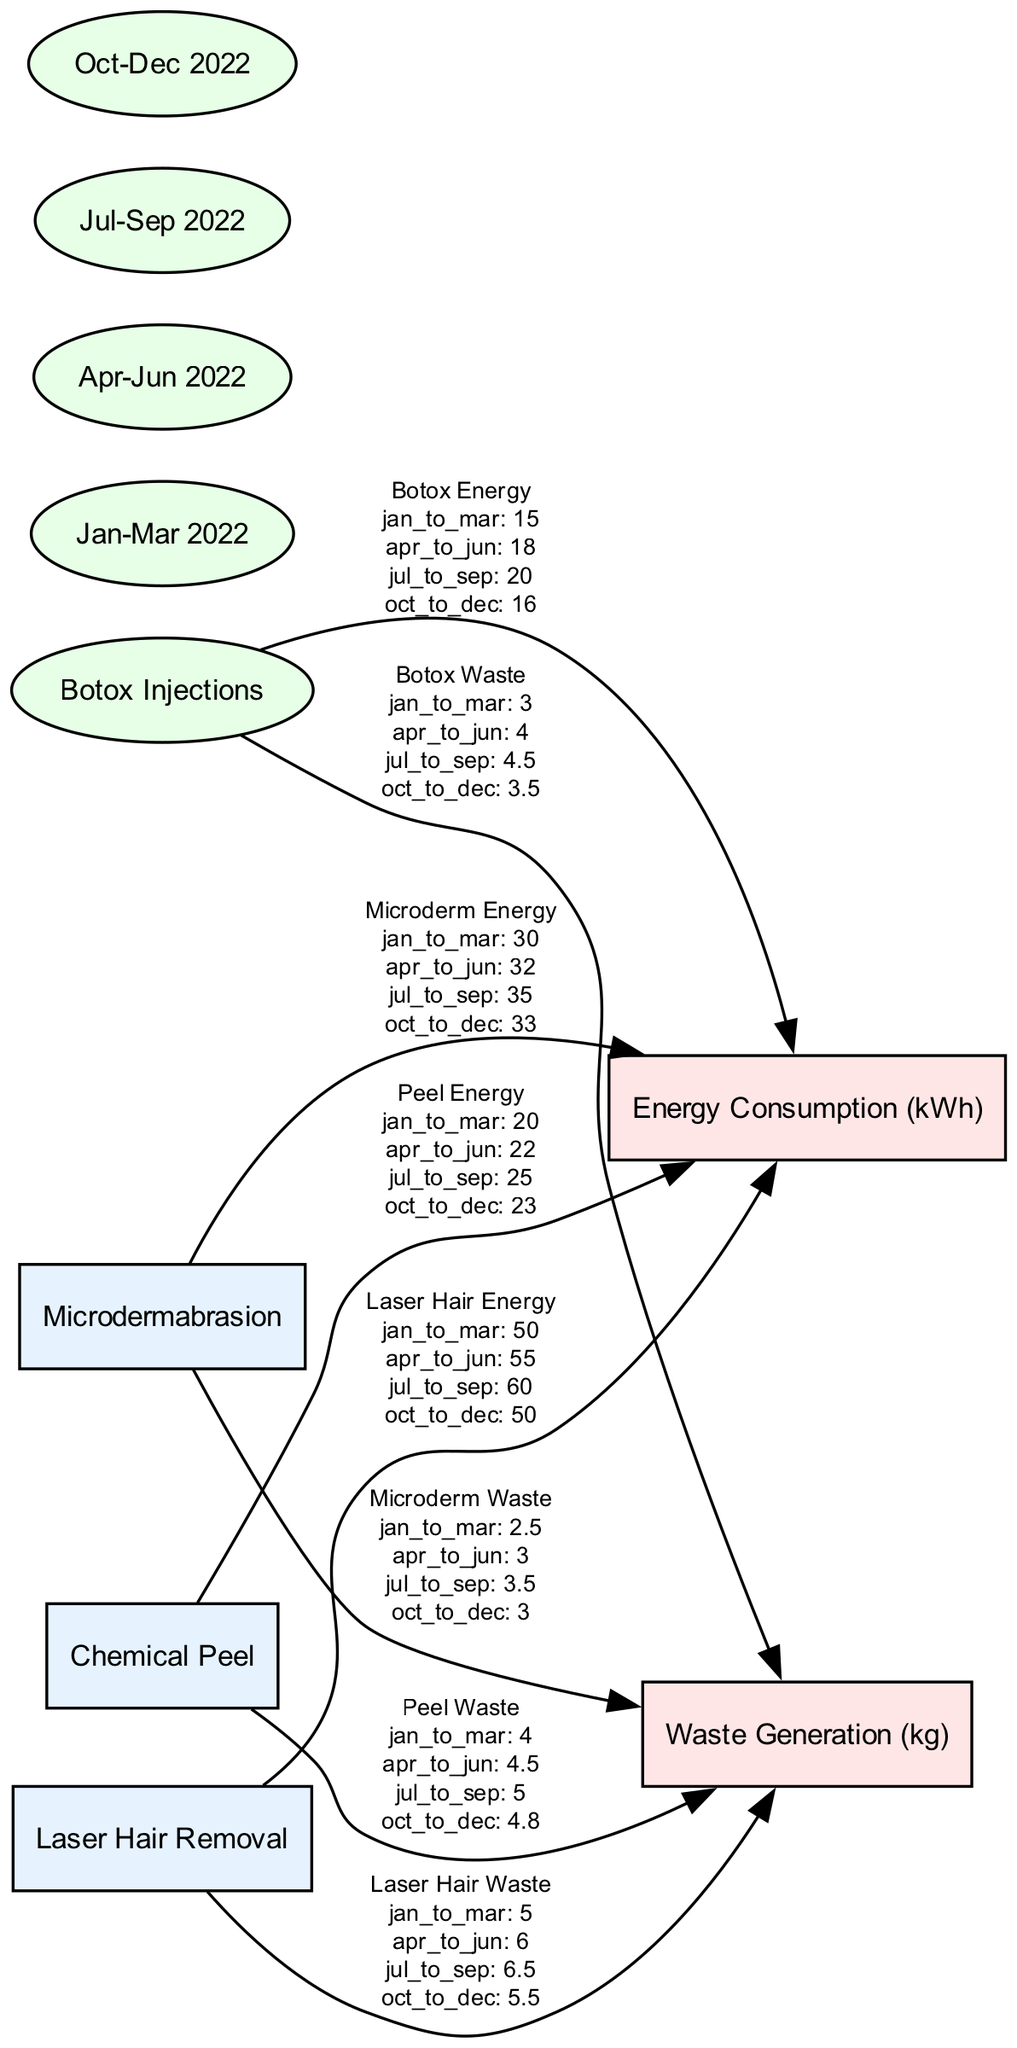What is the energy consumption for Botox Injections in May? The diagram lists the energy consumption values for each quarter. Botox Injections consume 18 kWh in the second quarter (April to June), which includes May.
Answer: 18 kWh How much waste is generated by Laser Hair Removal in the third quarter? The waste generation for Laser Hair Removal in the third quarter (July to September) is specifically stated as 6.5 kg in the diagram.
Answer: 6.5 kg What is the total number of cosmetic procedures represented in the diagram? The diagram includes four cosmetic procedures: Botox Injections, Laser Hair Removal, Chemical Peel, and Microdermabrasion. Therefore, the total count of procedures is 4.
Answer: 4 Which procedure has the highest energy consumption in the first quarter? Examining the energy consumption values for each procedure in the first quarter (January to March), Laser Hair Removal shows the highest consumption at 50 kWh.
Answer: Laser Hair Removal What is the amount of waste generated by Microdermabrasion in the fourth quarter? The waste generation for Microdermabrasion in the fourth quarter (October to December) is indicated as 3 kg, according to the data in the diagram.
Answer: 3 kg What was the trend in energy consumption for Chemical Peels from the first quarter to the fourth quarter? Observing the energy consumption values from the first quarter (20 kWh) to the fourth quarter (23 kWh), it can be seen that there was a steady increase over the year. Therefore, the trend is upward.
Answer: Upward Which cosmetic procedure generated the least amount of waste in the second quarter? In the second quarter (April to June), the waste generation values show that Microdermabrasion generated 3 kg, which is less than Chemical Peel (4.5 kg), Botox (4 kg), and Laser Hair Removal (6 kg), making it the least waste generator.
Answer: Microdermabrasion What was the total energy consumption for all procedures in the third quarter? To find this, add the energy consumption for each procedure in the third quarter: Botox (20 kWh) + Laser Hair Removal (60 kWh) + Chemical Peel (25 kWh) + Microdermabrasion (35 kWh) = 140 kWh.
Answer: 140 kWh 